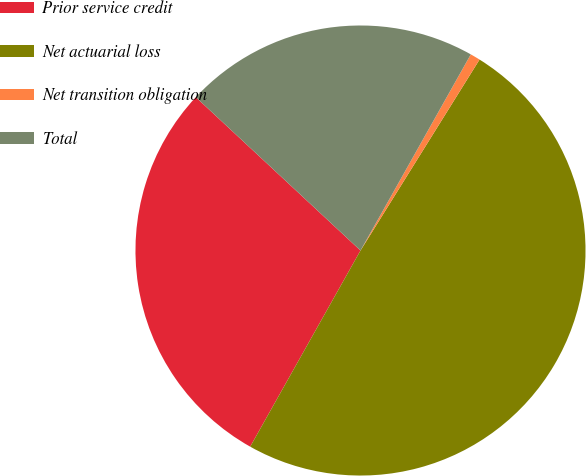Convert chart to OTSL. <chart><loc_0><loc_0><loc_500><loc_500><pie_chart><fcel>Prior service credit<fcel>Net actuarial loss<fcel>Net transition obligation<fcel>Total<nl><fcel>28.78%<fcel>49.28%<fcel>0.72%<fcel>21.22%<nl></chart> 